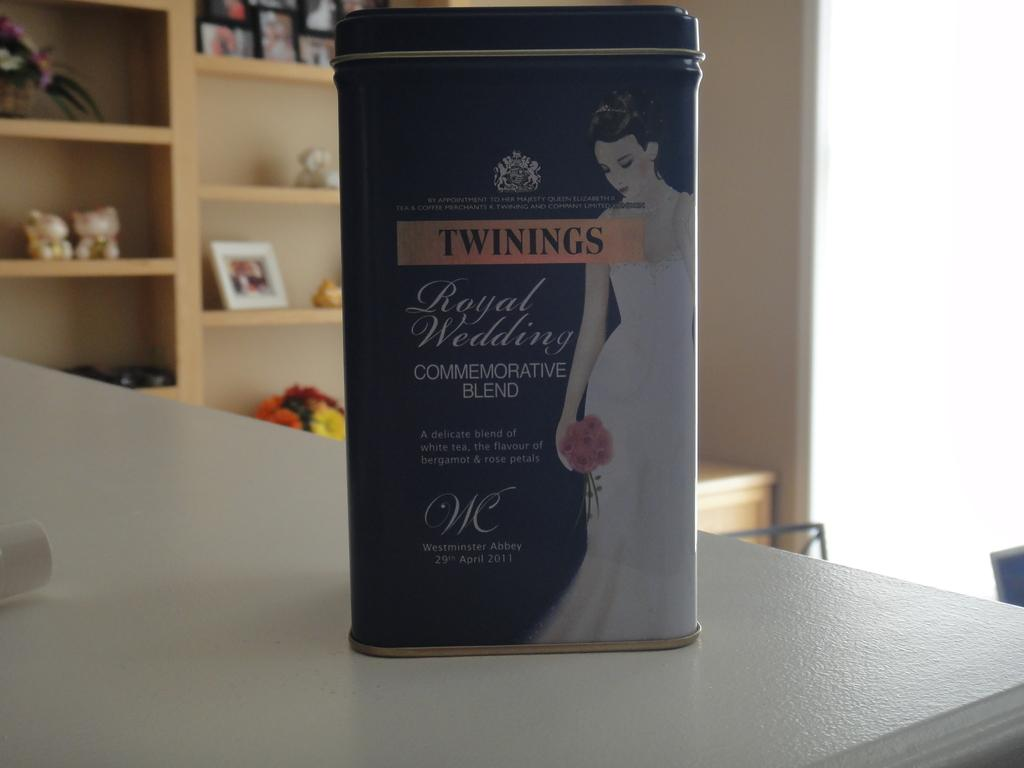Provide a one-sentence caption for the provided image. Box showing a bride on the box and says "Twinings". 